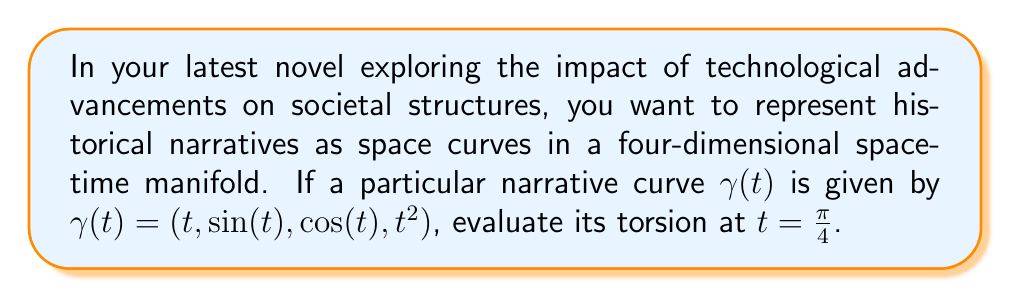Show me your answer to this math problem. To evaluate the torsion of the space curve, we'll follow these steps:

1) The torsion $\tau$ of a space curve $\gamma(t)$ is given by:

   $$\tau = \frac{(\gamma'(t) \times \gamma''(t)) \cdot \gamma'''(t)}{|\gamma'(t) \times \gamma''(t)|^2}$$

2) First, let's calculate $\gamma'(t)$, $\gamma''(t)$, and $\gamma'''(t)$:

   $\gamma'(t) = (1, \cos(t), -\sin(t), 2t)$
   $\gamma''(t) = (0, -\sin(t), -\cos(t), 2)$
   $\gamma'''(t) = (0, -\cos(t), \sin(t), 0)$

3) Now, let's calculate $\gamma'(t) \times \gamma''(t)$:

   $$\gamma'(t) \times \gamma''(t) = \begin{vmatrix} 
   \mathbf{i} & \mathbf{j} & \mathbf{k} & \mathbf{l} \\
   1 & \cos(t) & -\sin(t) & 2t \\
   0 & -\sin(t) & -\cos(t) & 2
   \end{vmatrix}$$

   $= (2\cos(t) + 2t\sin(t), 2\sin(t) - 2t\cos(t), -2, -\cos^2(t) - \sin^2(t))$
   $= (2\cos(t) + 2t\sin(t), 2\sin(t) - 2t\cos(t), -2, -1)$

4) The dot product $(\gamma'(t) \times \gamma''(t)) \cdot \gamma'''(t)$ is:

   $(2\cos(t) + 2t\sin(t))(-\cos(t)) + (2\sin(t) - 2t\cos(t))(\sin(t)) + (-2)(0) + (-1)(0)$
   $= -2\cos^2(t) - 2t\sin(t)\cos(t) + 2\sin^2(t) - 2t\sin(t)\cos(t)$
   $= -2\cos^2(t) + 2\sin^2(t) - 4t\sin(t)\cos(t)$
   $= 2(\sin^2(t) - \cos^2(t)) - 4t\sin(t)\cos(t)$
   $= -2\cos(2t) - 2t\sin(2t)$

5) The magnitude $|\gamma'(t) \times \gamma''(t)|^2$ is:

   $(2\cos(t) + 2t\sin(t))^2 + (2\sin(t) - 2t\cos(t))^2 + (-2)^2 + (-1)^2$
   $= 4\cos^2(t) + 8t\sin(t)\cos(t) + 4t^2\sin^2(t) + 4\sin^2(t) - 8t\sin(t)\cos(t) + 4t^2\cos^2(t) + 4 + 1$
   $= 4(\cos^2(t) + \sin^2(t)) + 4t^2(\sin^2(t) + \cos^2(t)) + 5$
   $= 4 + 4t^2 + 5 = 4t^2 + 9$

6) Therefore, the torsion is:

   $$\tau = \frac{-2\cos(2t) - 2t\sin(2t)}{4t^2 + 9}$$

7) At $t = \frac{\pi}{4}$, we have:

   $$\tau = \frac{-2\cos(\frac{\pi}{2}) - \frac{\pi}{2}\sin(\frac{\pi}{2})}{4(\frac{\pi}{4})^2 + 9} = \frac{-\frac{\pi}{2}}{\frac{\pi^2}{4} + 9}$$
Answer: $\frac{-2\pi}{\pi^2 + 36}$ 